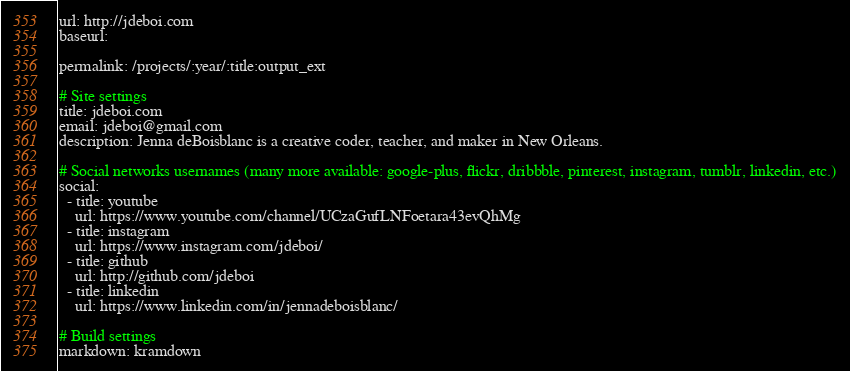Convert code to text. <code><loc_0><loc_0><loc_500><loc_500><_YAML_>url: http://jdeboi.com
baseurl:

permalink: /projects/:year/:title:output_ext

# Site settings
title: jdeboi.com
email: jdeboi@gmail.com
description: Jenna deBoisblanc is a creative coder, teacher, and maker in New Orleans.

# Social networks usernames (many more available: google-plus, flickr, dribbble, pinterest, instagram, tumblr, linkedin, etc.)
social:
  - title: youtube
    url: https://www.youtube.com/channel/UCzaGufLNFoetara43evQhMg
  - title: instagram
    url: https://www.instagram.com/jdeboi/
  - title: github
    url: http://github.com/jdeboi
  - title: linkedin
    url: https://www.linkedin.com/in/jennadeboisblanc/

# Build settings
markdown: kramdown
</code> 